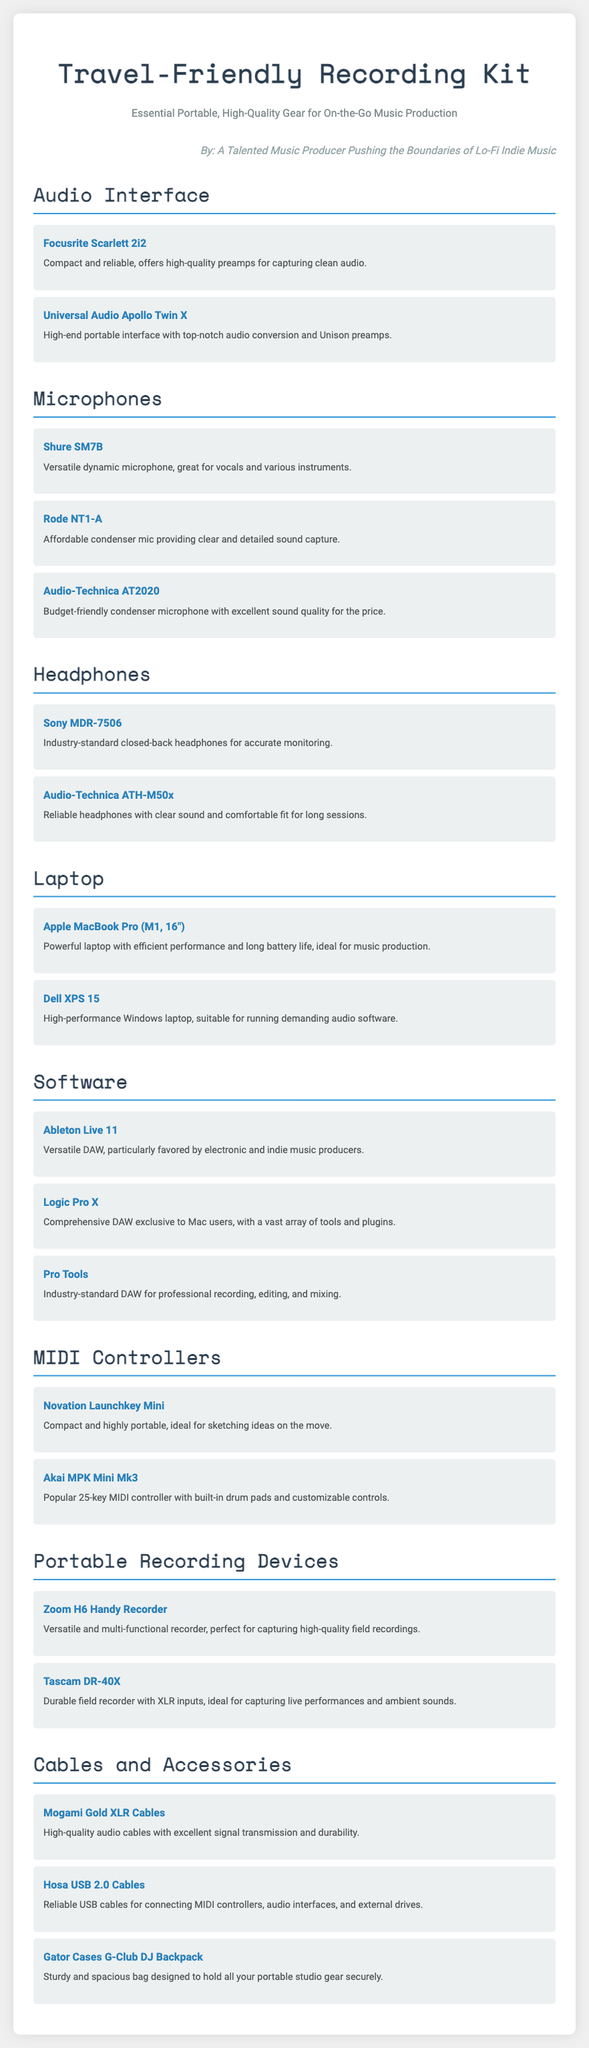What is the primary purpose of the document? The document is designed to provide a packing list for a mobile recording studio with portable, high-quality gear for on-the-go music production.
Answer: Packing list How many microphones are listed? The document lists three microphones under the Microphones section.
Answer: Three What is the name of a high-end audio interface mentioned? The document mentions the Universal Audio Apollo Twin X as a high-end audio interface.
Answer: Universal Audio Apollo Twin X Which software is exclusive to Mac users? Logic Pro X is identified in the document as the comprehensive DAW exclusive to Mac users.
Answer: Logic Pro X What type of headphones is the Sony MDR-7506? The Sony MDR-7506 is described as industry-standard closed-back headphones.
Answer: Closed-back Which MIDI controller has built-in drum pads? The Akai MPK Mini Mk3 is specified as the popular 25-key MIDI controller with built-in drum pads.
Answer: Akai MPK Mini Mk3 What item is recommended for secure gear storage? The Gator Cases G-Club DJ Backpack is suggested in the document for holding all portable studio gear securely.
Answer: Gator Cases G-Club DJ Backpack What type of cables does the document emphasize for audio? The document emphasizes Mogami Gold XLR Cables as high-quality audio cables.
Answer: XLR Cables Which portable recording device is versatile and multi-functional? The Zoom H6 Handy Recorder is noted as versatile and multi-functional for capturing high-quality field recordings.
Answer: Zoom H6 Handy Recorder How many portable recording devices are mentioned? The document mentions two portable recording devices: Zoom H6 and Tascam DR-40X.
Answer: Two 